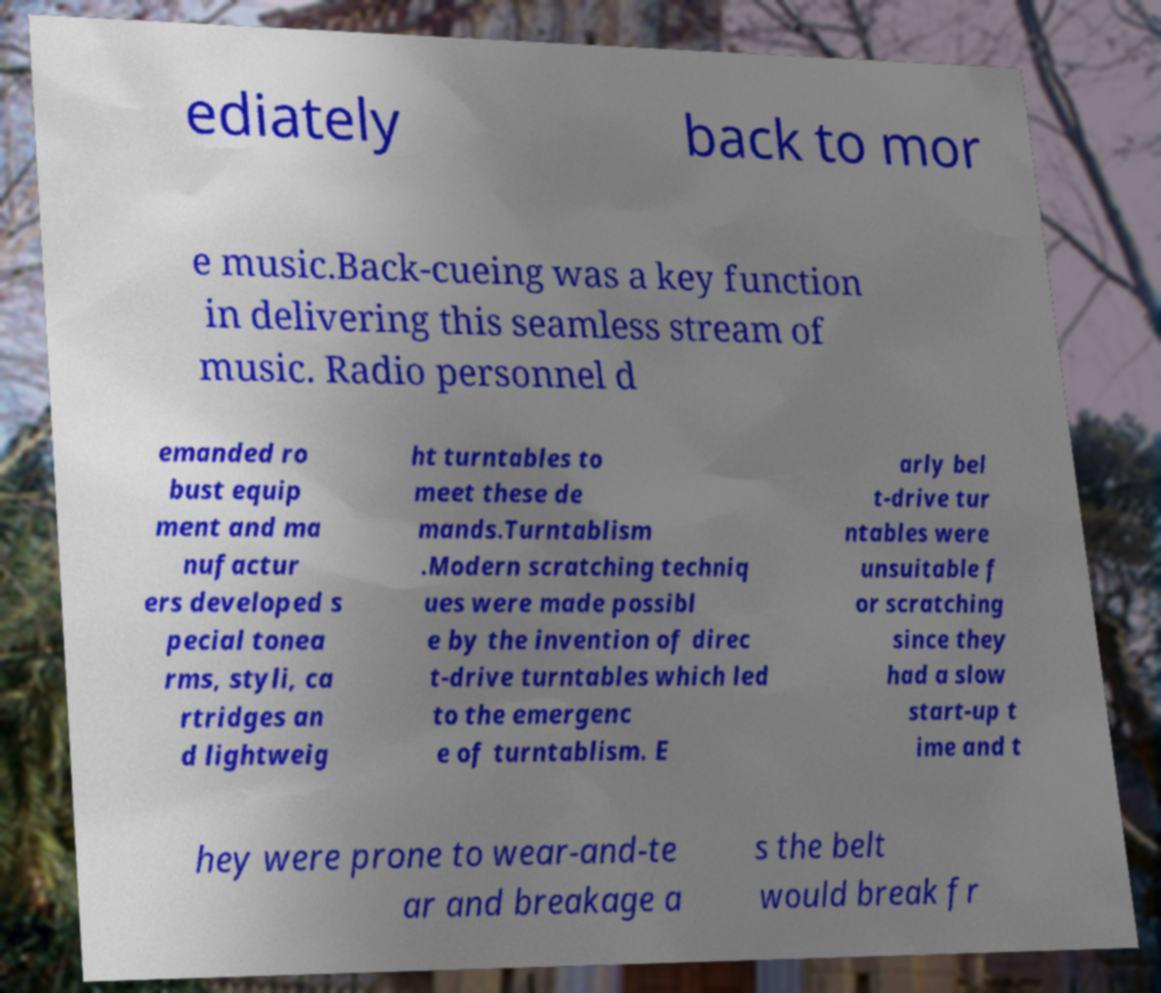Please read and relay the text visible in this image. What does it say? ediately back to mor e music.Back-cueing was a key function in delivering this seamless stream of music. Radio personnel d emanded ro bust equip ment and ma nufactur ers developed s pecial tonea rms, styli, ca rtridges an d lightweig ht turntables to meet these de mands.Turntablism .Modern scratching techniq ues were made possibl e by the invention of direc t-drive turntables which led to the emergenc e of turntablism. E arly bel t-drive tur ntables were unsuitable f or scratching since they had a slow start-up t ime and t hey were prone to wear-and-te ar and breakage a s the belt would break fr 